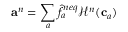Convert formula to latex. <formula><loc_0><loc_0><loc_500><loc_500>a ^ { n } = \sum _ { a } \hat { f } _ { a } ^ { n e q } \mathcal { H } ^ { n } ( c _ { a } )</formula> 